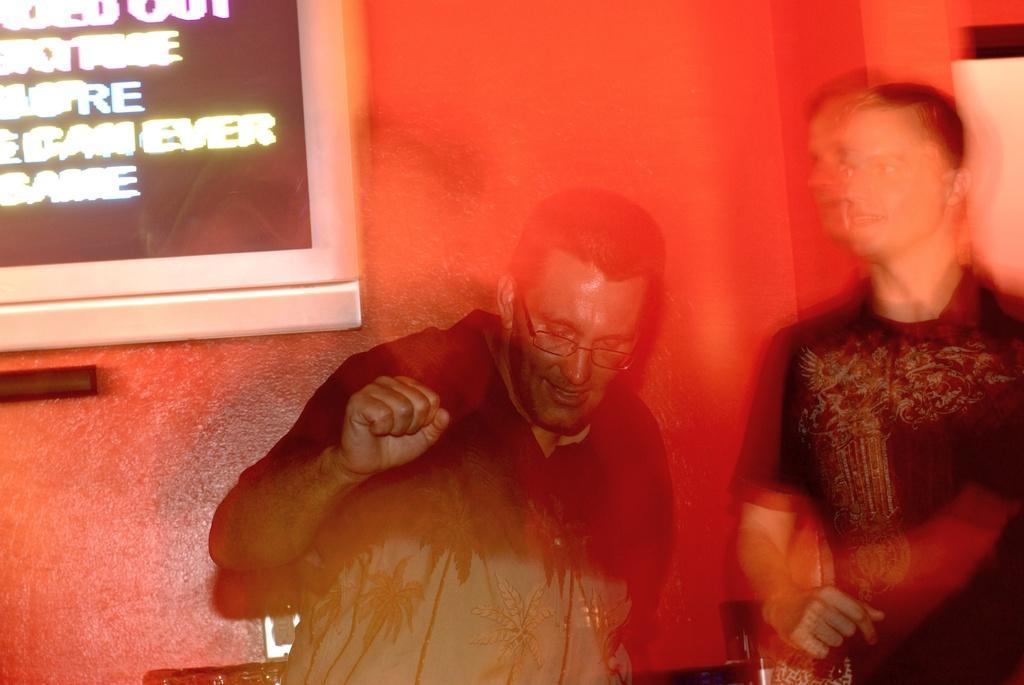Can you describe this image briefly? Here we can see two people. This man wore spectacles and looking downwards. On red wall there is a screen. 